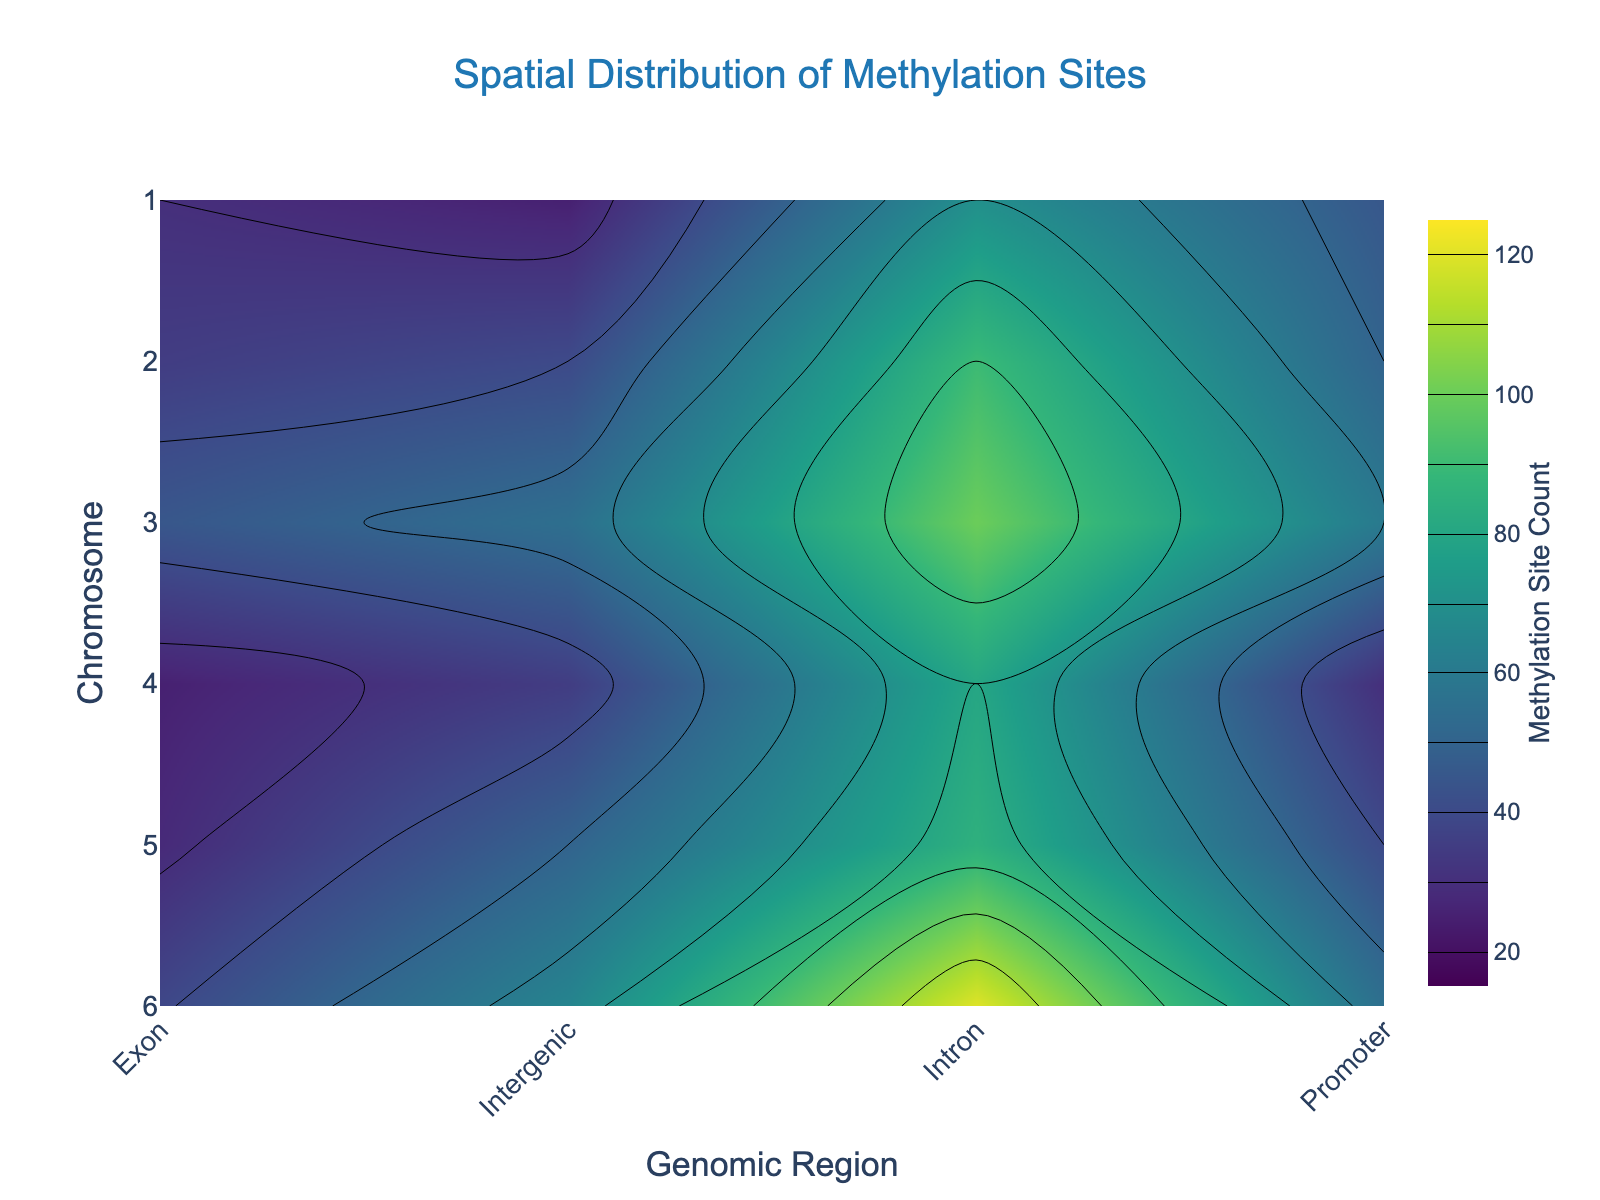What is the contour plot's title? The title is displayed at the top of the plot in a larger font size and different color. It states what the plot is about.
Answer: Spatial Distribution of Methylation Sites How many genomic regions are analyzed in this plot? The x-axis represents the genomic regions, and there are specific tick labels corresponding to these regions. Count the labels to find the answer.
Answer: 4 Which chromosome shows the highest methylation site count in the exon region? The plot allows you to examine the contour values across different chromosomes and genomic regions. Identify the highest contour in the exon region.
Answer: Chromosome 6 What is the methylation site count in the promoter region for Chromosome 4? Locate Chromosome 4 on the y-axis and trace it to the contour value in the Promoter region on the x-axis. The hover feature or color scale can help identify the value.
Answer: 30 Among all genomic regions and chromosomes, which one has the minimum methylation site count and what is it? Examine the contour plot to identify the lowest value present in the entire plot, based on the color scheme ranging from low to high values.
Answer: Intergenic region in Chromosome 1 with a count of 25 What is the average methylation site count for all regions in Chromosome 2? Sum the contour values for Chromosome 2 across all genomic regions and divide by the number of regions (4).
Answer: (50 + 35 + 90 + 40) / 4 = 53.75 Which genomic region has the largest range of methylation site counts across all chromosomes? For each genomic region on the x-axis, identify the maximum and minimum contour values, then calculate the range (max - min) and compare the results for all regions.
Answer: Intron (range = 120 - 70 = 50) How does the methylation site count trend in the intron region change from Chromosome 1 to Chromosome 6? Trace the contour values for the intron region from Chromosome 1 to Chromosome 6 on the y-axis, noting whether the values generally increase, decrease, or stay constant.
Answer: Increasing In which genomic region and chromosome combination does the methylation site count first exceed 100? By examining the contour plot, find the point where the count surpasses 100, using the color scale and contour lines as a guide.
Answer: Intron region in Chromosome 3 Which genomic region shows the most variability (i.e., fluctuation) in methylation site counts across different chromosomes? Assess the differences in contour values for each genomic region across all chromosomes, looking for the largest variability in counts.
Answer: Intron 